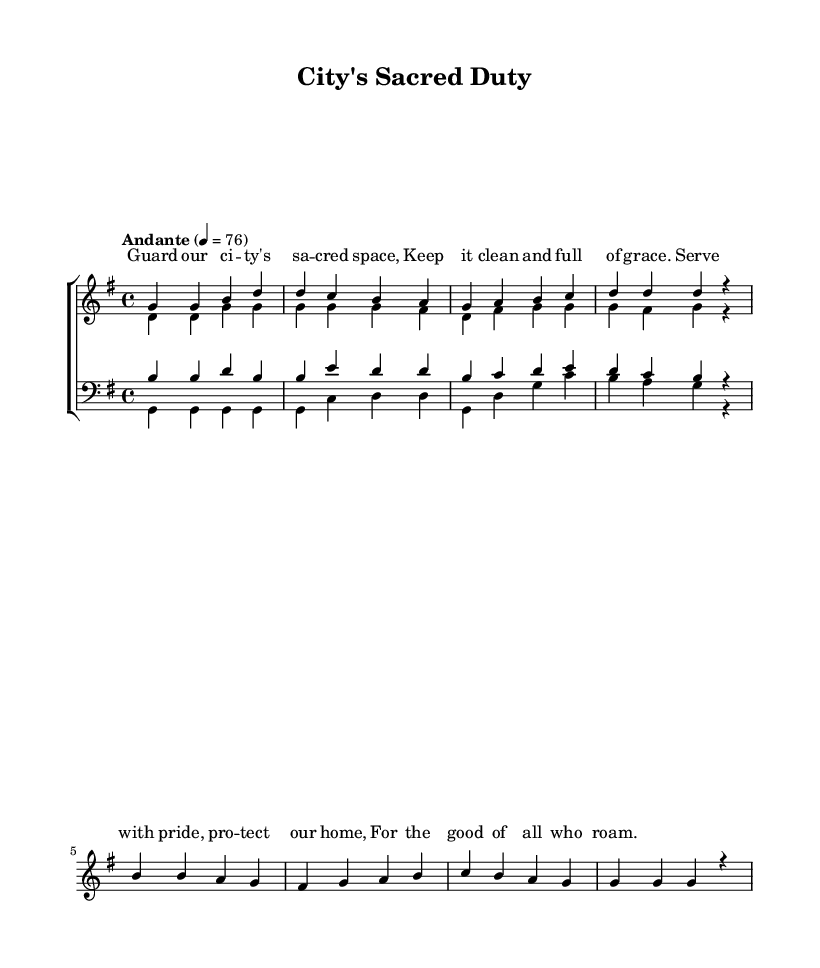What is the key signature of this music? The key signature is G major, which has one sharp (F#). This can be identified at the beginning of the staff where the sharp is placed.
Answer: G major What is the time signature indicated in the music? The time signature is 4/4, which appears at the beginning of the score. This means there are four beats in each measure, and the quarter note gets one beat.
Answer: 4/4 What is the tempo marking of this piece? The tempo marking is "Andante," which indicates a moderate speed. This marking is often written above the first staff in the score, generally suggesting a walking pace.
Answer: Andante How many measures are in the soprano part of the music? The soprano part contains eight measures. This can be counted by observing the individual sections separated by vertical lines on the staff.
Answer: 8 What are the lyrics associated with the first voice? The lyrics associated with the first voice (sopranos) are "Guard our city's sacred space." These lyrics are written directly below the notes in the soprano staff.
Answer: Guard our city's sacred space Which voice has the lowest range in this choir arrangement? The bass voice has the lowest range in this arrangement as it is specifically written for the lower vocal register, indicated by the clef used on their staff.
Answer: Bass How many distinct musical parts are present in the choir arrangement? There are four distinct musical parts in this choir arrangement: soprano, alto, tenor, and bass. This is indicated by the separate staff sections designated for each voice in the layout of the score.
Answer: Four 